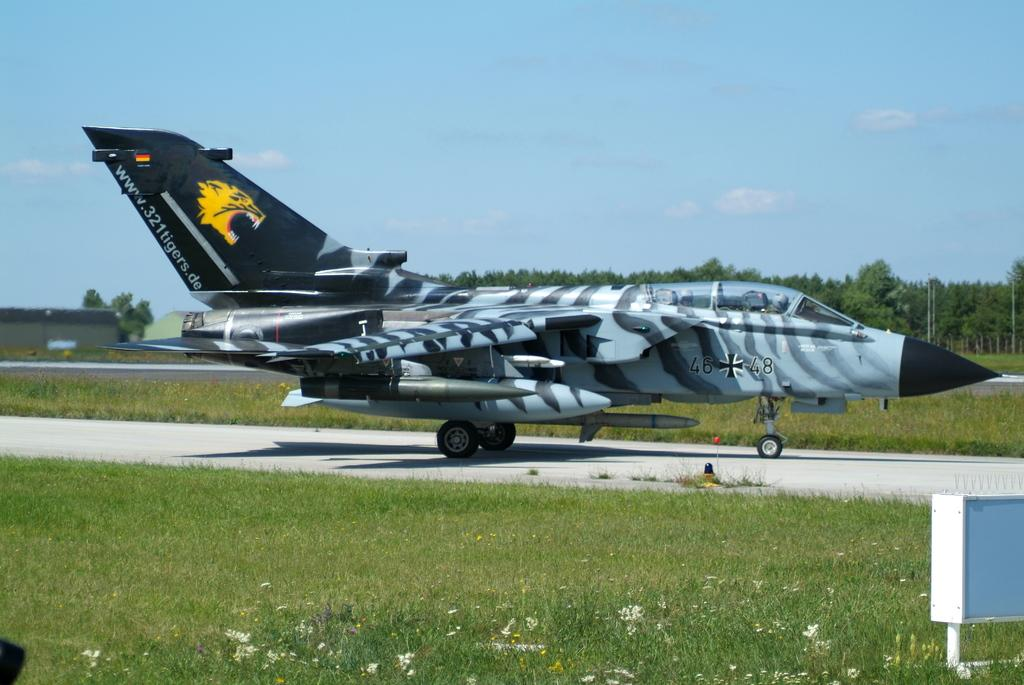<image>
Relay a brief, clear account of the picture shown. An airplane has the German flag and a German website painted on its tail. 